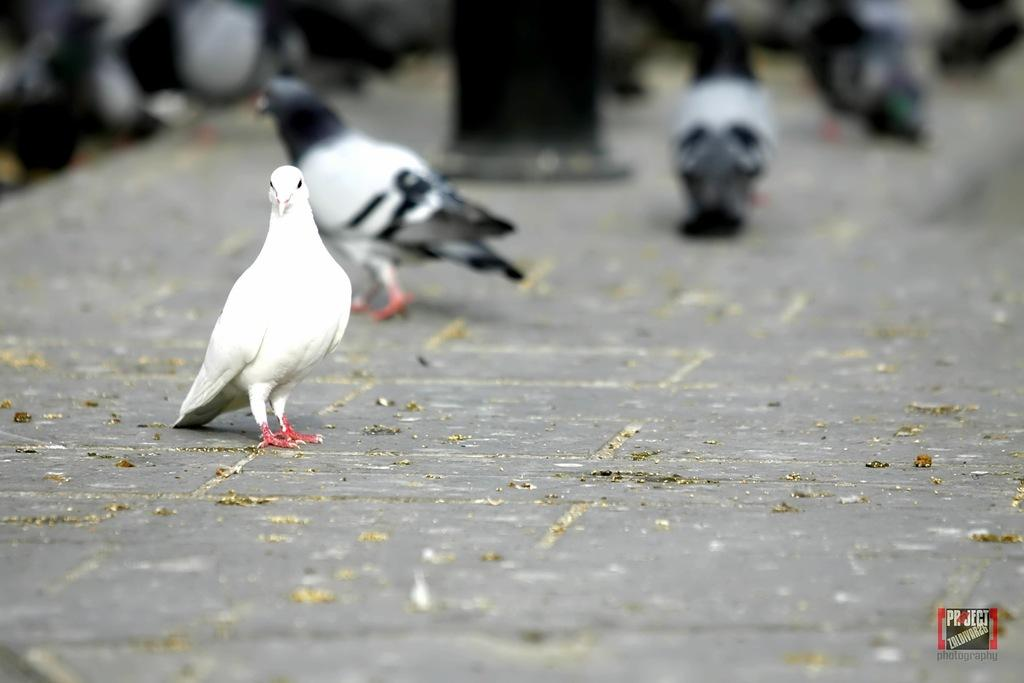What type of bird can be seen on the street in the image? There is a white color bird on the street in the image. How many birds are standing near the black pole? There are many birds standing near a black pole in the image. Can you describe any additional features or elements in the image? There is a watermark in the bottom right corner of the image. What mode of transport is being used by the birds to compare their orders? There is no mode of transport or order comparison present in the image; it features birds on a street and near a black pole. 